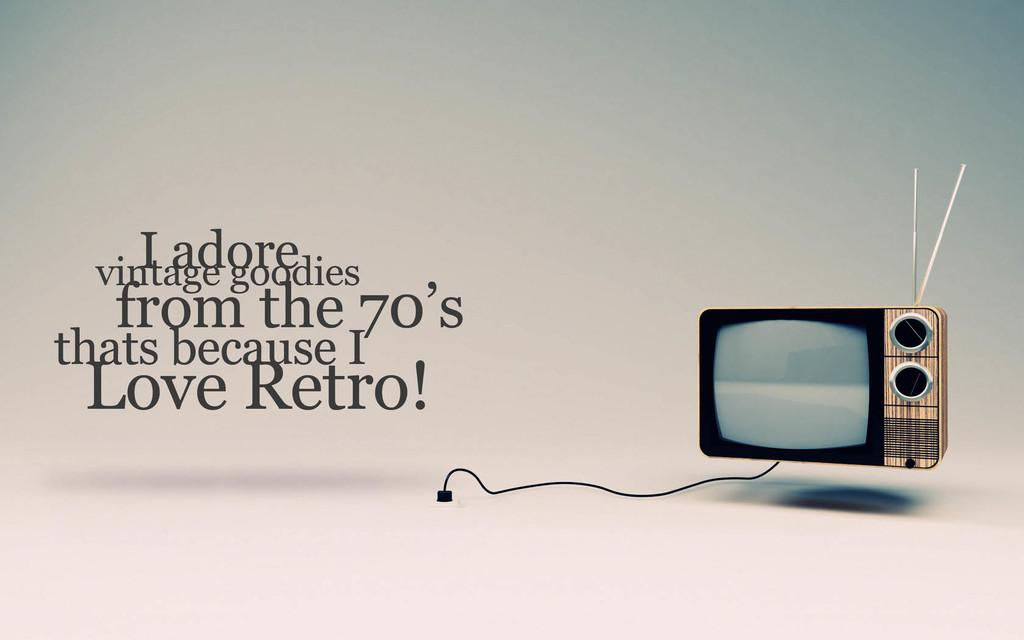<image>
Summarize the visual content of the image. A TV on a white background with text that says Ladore vintage goodies from the 70's thats because I Love Retro. 